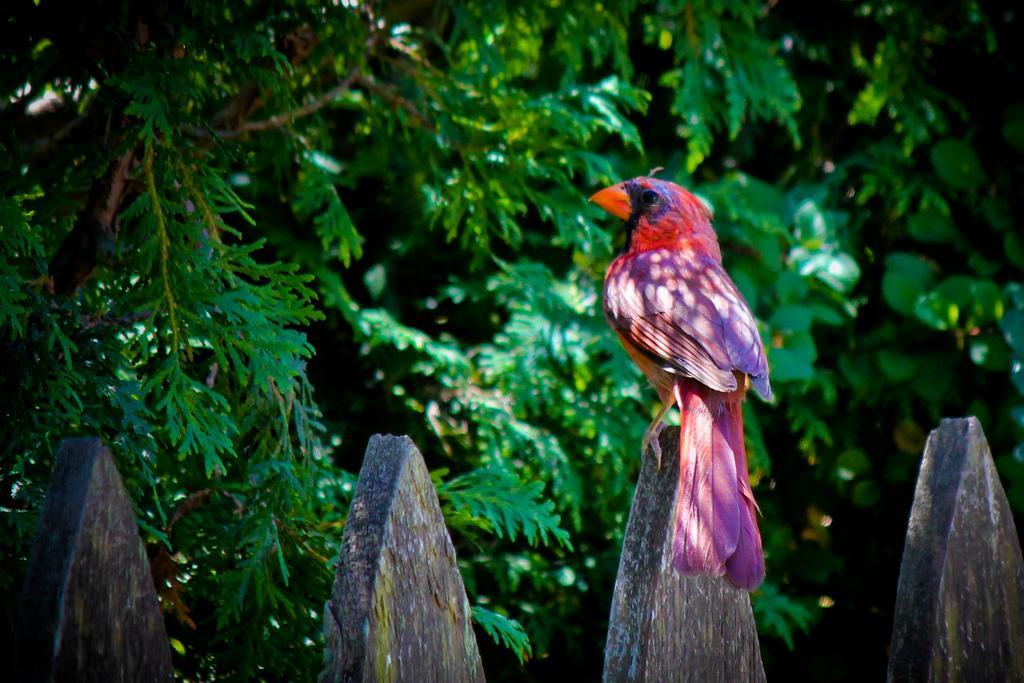Could you give a brief overview of what you see in this image? In this image there is one bird is sitting on a wooden thing as we can see on the right side of this image. There are some trees in the background. There are some wooden things are present in the bottom of this image. 